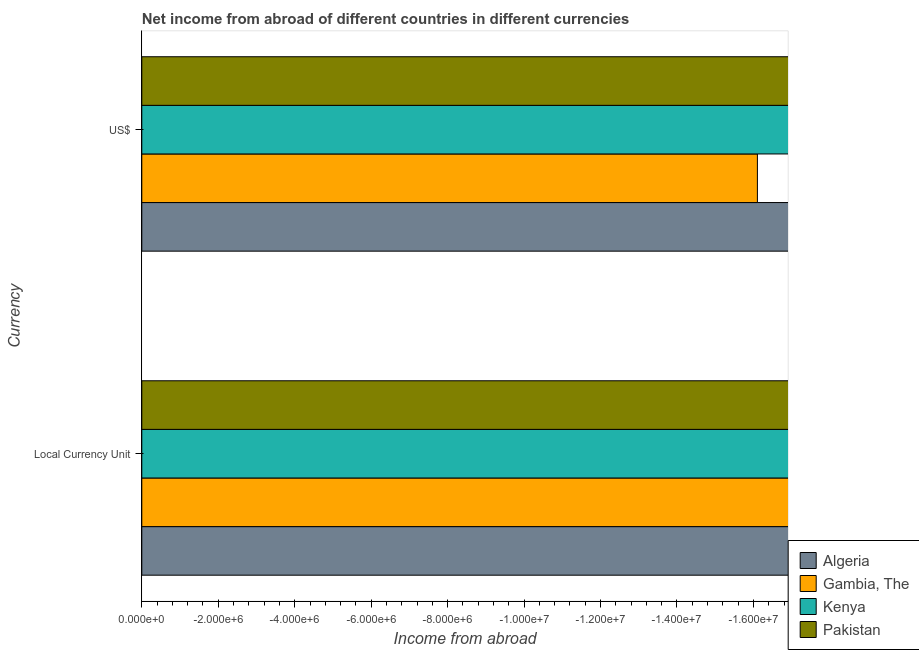How many different coloured bars are there?
Ensure brevity in your answer.  0. Are the number of bars per tick equal to the number of legend labels?
Keep it short and to the point. No. How many bars are there on the 2nd tick from the top?
Offer a terse response. 0. How many bars are there on the 1st tick from the bottom?
Keep it short and to the point. 0. What is the label of the 1st group of bars from the top?
Your answer should be very brief. US$. Across all countries, what is the minimum income from abroad in constant 2005 us$?
Ensure brevity in your answer.  0. Are all the bars in the graph horizontal?
Your response must be concise. Yes. Does the graph contain grids?
Keep it short and to the point. No. How are the legend labels stacked?
Provide a short and direct response. Vertical. What is the title of the graph?
Your response must be concise. Net income from abroad of different countries in different currencies. What is the label or title of the X-axis?
Make the answer very short. Income from abroad. What is the label or title of the Y-axis?
Offer a terse response. Currency. What is the Income from abroad in Algeria in Local Currency Unit?
Offer a terse response. 0. What is the Income from abroad in Gambia, The in Local Currency Unit?
Ensure brevity in your answer.  0. What is the Income from abroad of Kenya in Local Currency Unit?
Provide a short and direct response. 0. What is the Income from abroad of Pakistan in Local Currency Unit?
Provide a short and direct response. 0. What is the Income from abroad of Gambia, The in US$?
Offer a very short reply. 0. What is the Income from abroad of Kenya in US$?
Give a very brief answer. 0. What is the Income from abroad in Pakistan in US$?
Give a very brief answer. 0. What is the total Income from abroad in Algeria in the graph?
Keep it short and to the point. 0. What is the total Income from abroad of Pakistan in the graph?
Offer a very short reply. 0. What is the average Income from abroad in Algeria per Currency?
Provide a succinct answer. 0. What is the average Income from abroad in Pakistan per Currency?
Keep it short and to the point. 0. 